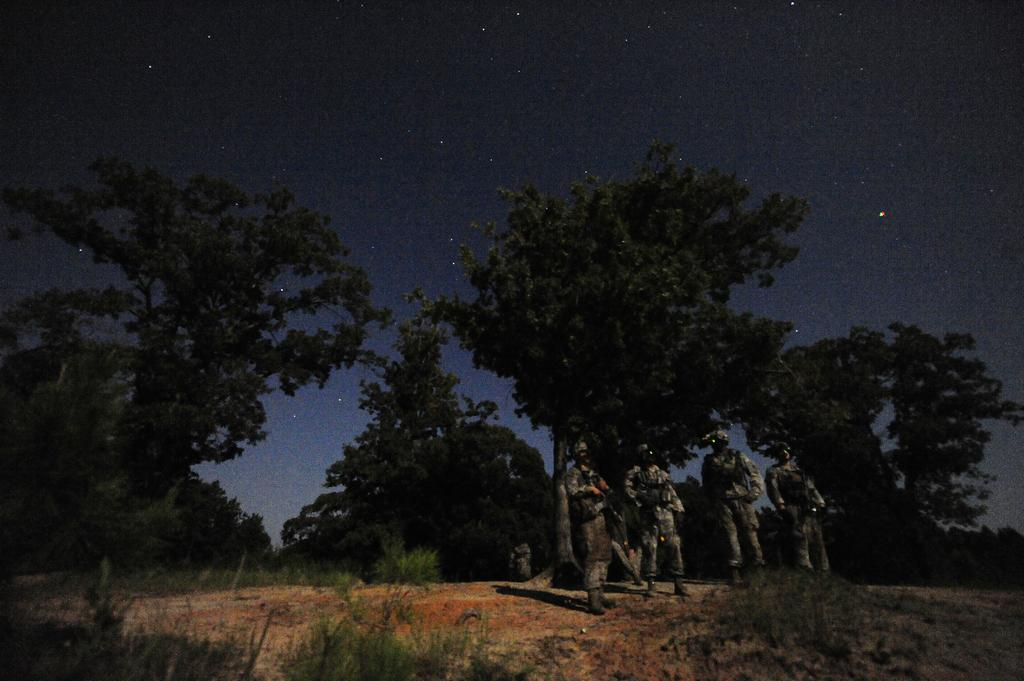What type of people are present in the image? There are soldiers in the image. What are the soldiers holding in their hands? The soldiers are holding objects. What is the ground surface like in the image? There is grass on the ground in the image. What other types of vegetation can be seen in the image? There are plants and trees in the image. How would you describe the sky in the image? The sky is dark in the image, and stars are visible. What type of brake is being used by the soldiers in the image? There is no brake present in the image; the soldiers are holding objects, but they are not brakes. How does the iron affect the throat of the soldiers in the image? There is no iron or mention of throats in the image; the soldiers are holding objects, but they are not related to iron or throats. 